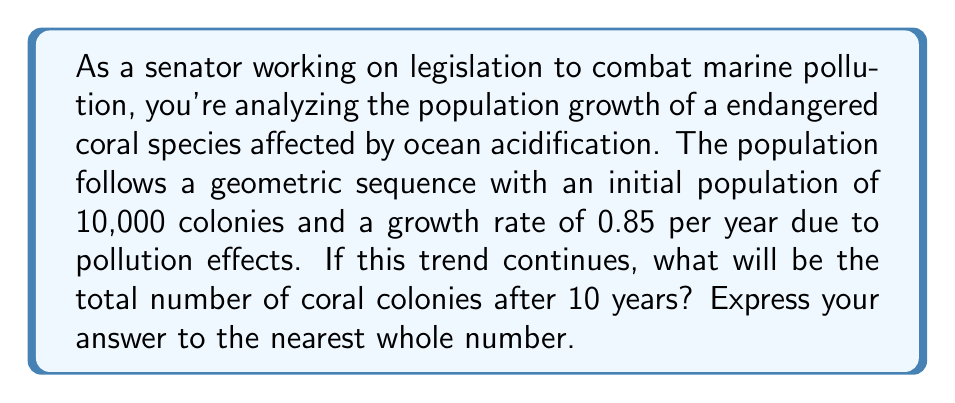Can you solve this math problem? To solve this problem, we'll use the formula for the nth term of a geometric sequence:

$$a_n = a_1 \cdot r^{n-1}$$

Where:
$a_n$ is the nth term (population after n years)
$a_1$ is the initial term (initial population)
$r$ is the common ratio (growth rate)
$n$ is the number of terms (years)

Given:
$a_1 = 10,000$ (initial population)
$r = 0.85$ (growth rate)
$n = 10$ (years)

Let's calculate the population after 10 years:

$$a_{10} = 10,000 \cdot 0.85^{10-1}$$
$$a_{10} = 10,000 \cdot 0.85^9$$

Using a calculator or computing software:

$$a_{10} = 10,000 \cdot 0.2316$$
$$a_{10} = 2,316.097$$

Rounding to the nearest whole number:

$$a_{10} \approx 2,316$$
Answer: 2,316 coral colonies 